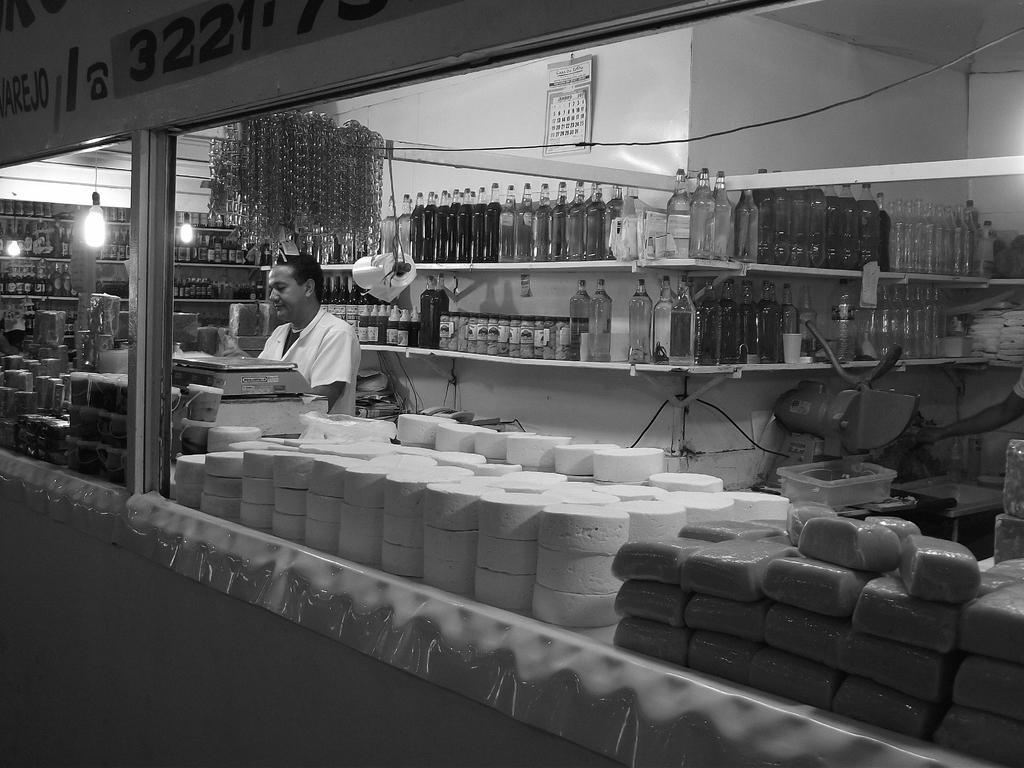Please provide a concise description of this image. This is a black and white image. In this image we can see a shop. On the ship something is written. Also there are many items. And there is a weighing machine. And there is a person standing. And there are lights. In the back there is a wall with a calendar. Also there are racks. On the racks there are bottles. And there is a box. Also there is a machine. 